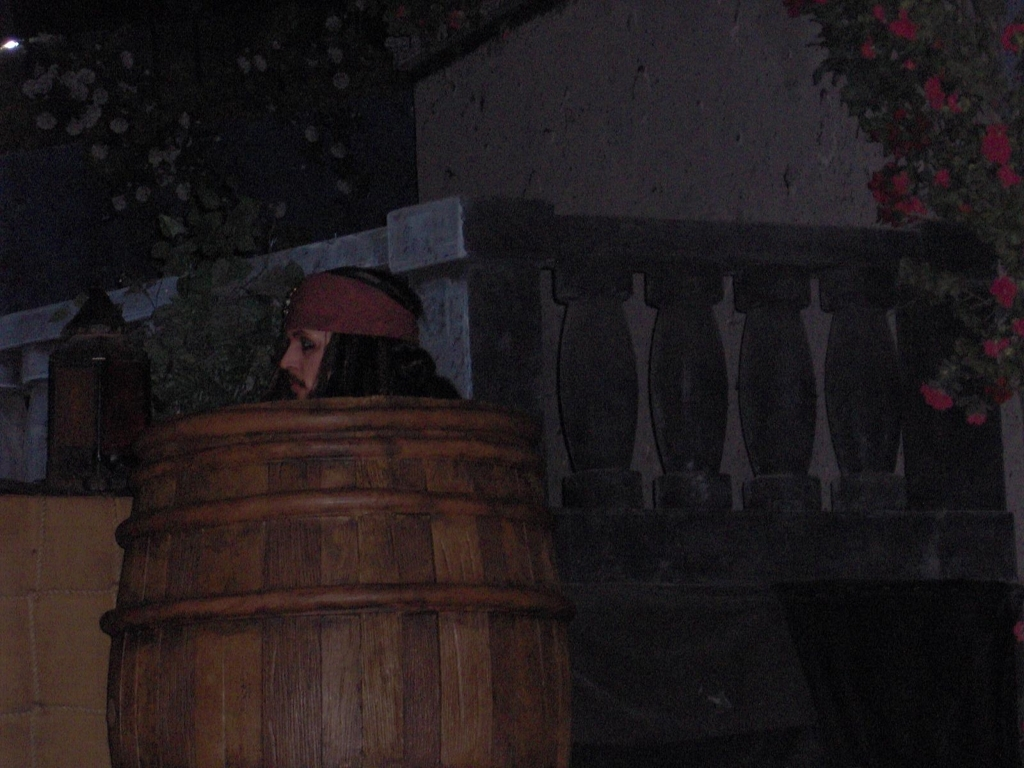Could this image be part of a larger event, like a festival or a fair? It's possible, as the barrel and foliage give the impression of a renaissance fair or an outdoor market. However, the lack of people and celebratory indicators makes this less likely. What elements in this image suggest an older historical period to you? The wooden barrel, the stony wall, and the style of the person's headwear all suggest a setting that could be reminiscent of times gone by, perhaps the medieval or renaissance period. 